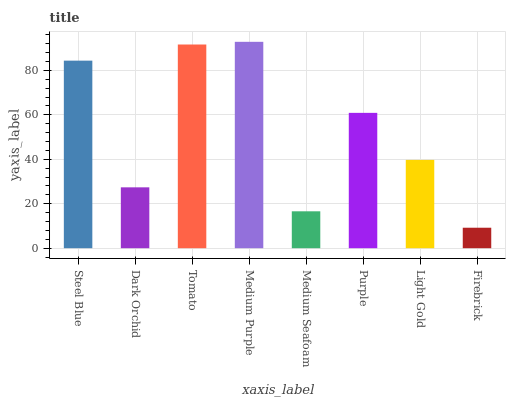Is Dark Orchid the minimum?
Answer yes or no. No. Is Dark Orchid the maximum?
Answer yes or no. No. Is Steel Blue greater than Dark Orchid?
Answer yes or no. Yes. Is Dark Orchid less than Steel Blue?
Answer yes or no. Yes. Is Dark Orchid greater than Steel Blue?
Answer yes or no. No. Is Steel Blue less than Dark Orchid?
Answer yes or no. No. Is Purple the high median?
Answer yes or no. Yes. Is Light Gold the low median?
Answer yes or no. Yes. Is Dark Orchid the high median?
Answer yes or no. No. Is Tomato the low median?
Answer yes or no. No. 